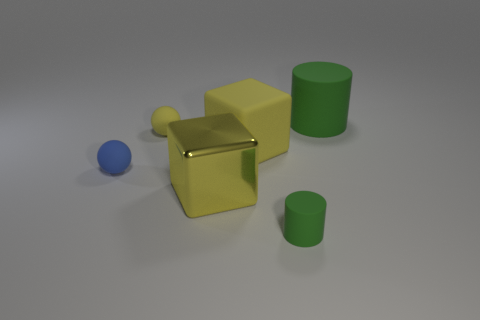Is there a blue object that has the same material as the tiny green thing? Indeed, the blue object, which appears to be a small sphere, shares the same smooth and matte appearance as the tiny green cylinder, indicating that their materials could be the same. 